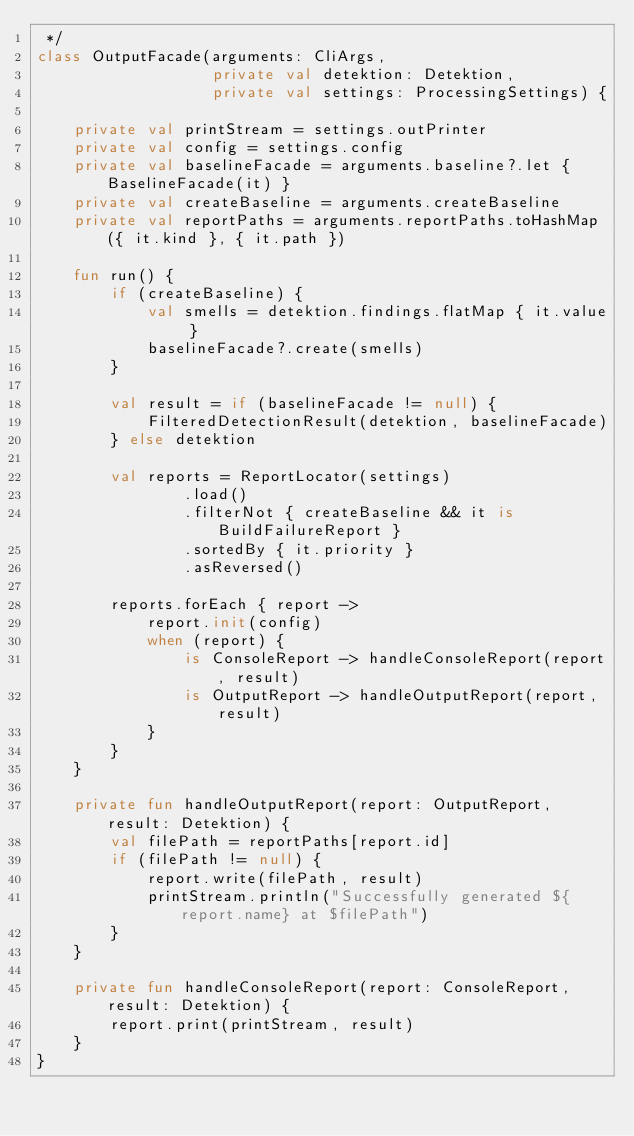Convert code to text. <code><loc_0><loc_0><loc_500><loc_500><_Kotlin_> */
class OutputFacade(arguments: CliArgs,
				   private val detektion: Detektion,
				   private val settings: ProcessingSettings) {

	private val printStream = settings.outPrinter
	private val config = settings.config
	private val baselineFacade = arguments.baseline?.let { BaselineFacade(it) }
	private val createBaseline = arguments.createBaseline
	private val reportPaths = arguments.reportPaths.toHashMap({ it.kind }, { it.path })

	fun run() {
		if (createBaseline) {
			val smells = detektion.findings.flatMap { it.value }
			baselineFacade?.create(smells)
		}

		val result = if (baselineFacade != null) {
			FilteredDetectionResult(detektion, baselineFacade)
		} else detektion

		val reports = ReportLocator(settings)
				.load()
				.filterNot { createBaseline && it is BuildFailureReport }
				.sortedBy { it.priority }
				.asReversed()

		reports.forEach { report ->
			report.init(config)
			when (report) {
				is ConsoleReport -> handleConsoleReport(report, result)
				is OutputReport -> handleOutputReport(report, result)
			}
		}
	}

	private fun handleOutputReport(report: OutputReport, result: Detektion) {
		val filePath = reportPaths[report.id]
		if (filePath != null) {
			report.write(filePath, result)
			printStream.println("Successfully generated ${report.name} at $filePath")
		}
	}

	private fun handleConsoleReport(report: ConsoleReport, result: Detektion) {
		report.print(printStream, result)
	}
}
</code> 